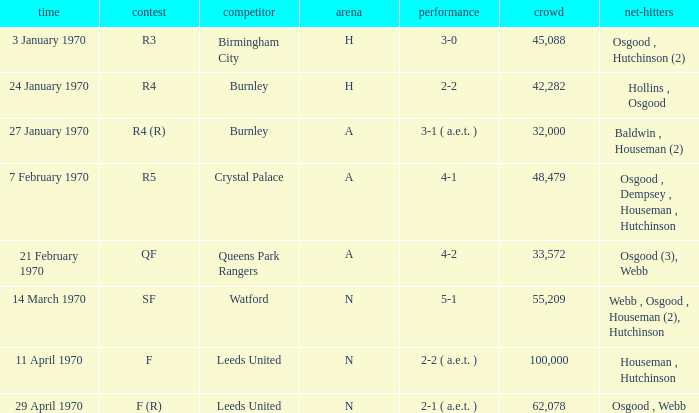What round was the game with a result of 5-1 at N venue? SF. 